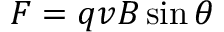<formula> <loc_0><loc_0><loc_500><loc_500>F = q v B \sin \theta</formula> 